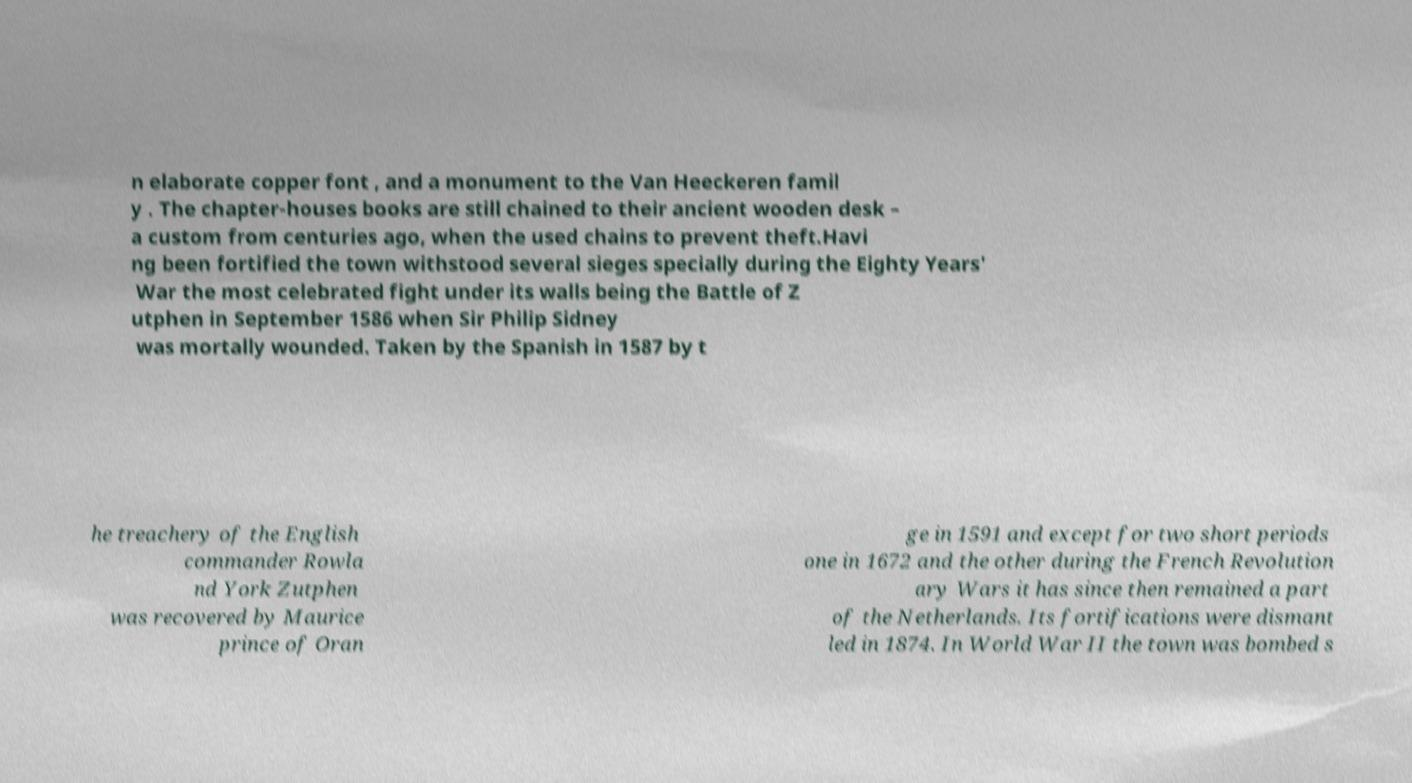Can you accurately transcribe the text from the provided image for me? n elaborate copper font , and a monument to the Van Heeckeren famil y . The chapter-houses books are still chained to their ancient wooden desk – a custom from centuries ago, when the used chains to prevent theft.Havi ng been fortified the town withstood several sieges specially during the Eighty Years' War the most celebrated fight under its walls being the Battle of Z utphen in September 1586 when Sir Philip Sidney was mortally wounded. Taken by the Spanish in 1587 by t he treachery of the English commander Rowla nd York Zutphen was recovered by Maurice prince of Oran ge in 1591 and except for two short periods one in 1672 and the other during the French Revolution ary Wars it has since then remained a part of the Netherlands. Its fortifications were dismant led in 1874. In World War II the town was bombed s 